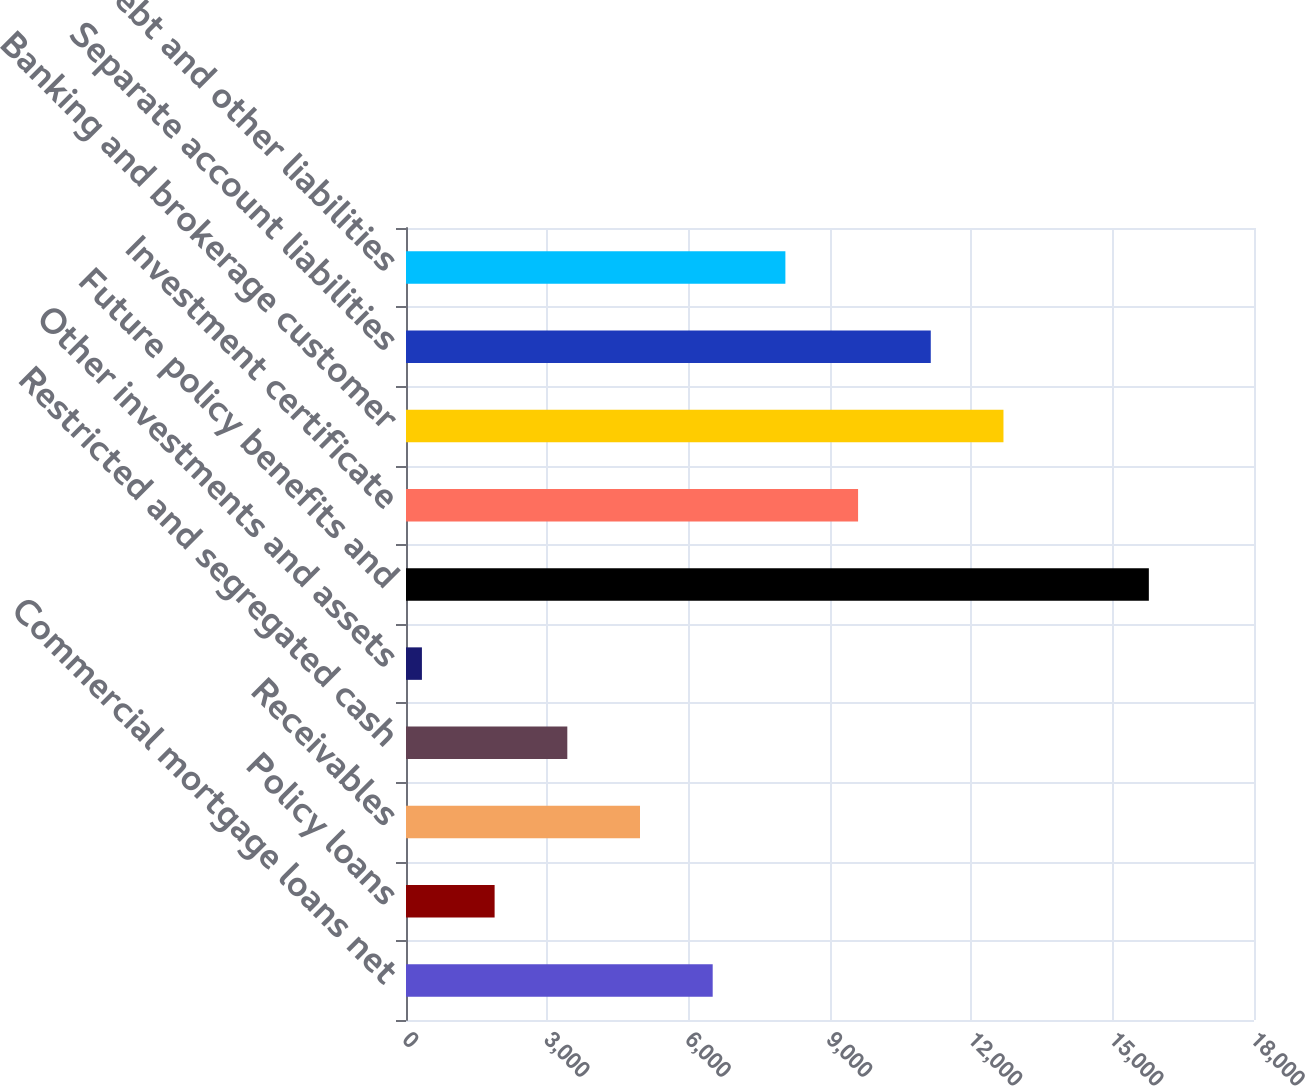Convert chart to OTSL. <chart><loc_0><loc_0><loc_500><loc_500><bar_chart><fcel>Commercial mortgage loans net<fcel>Policy loans<fcel>Receivables<fcel>Restricted and segregated cash<fcel>Other investments and assets<fcel>Future policy benefits and<fcel>Investment certificate<fcel>Banking and brokerage customer<fcel>Separate account liabilities<fcel>Debt and other liabilities<nl><fcel>6510<fcel>1881<fcel>4967<fcel>3424<fcel>338<fcel>15768<fcel>9596<fcel>12682<fcel>11139<fcel>8053<nl></chart> 